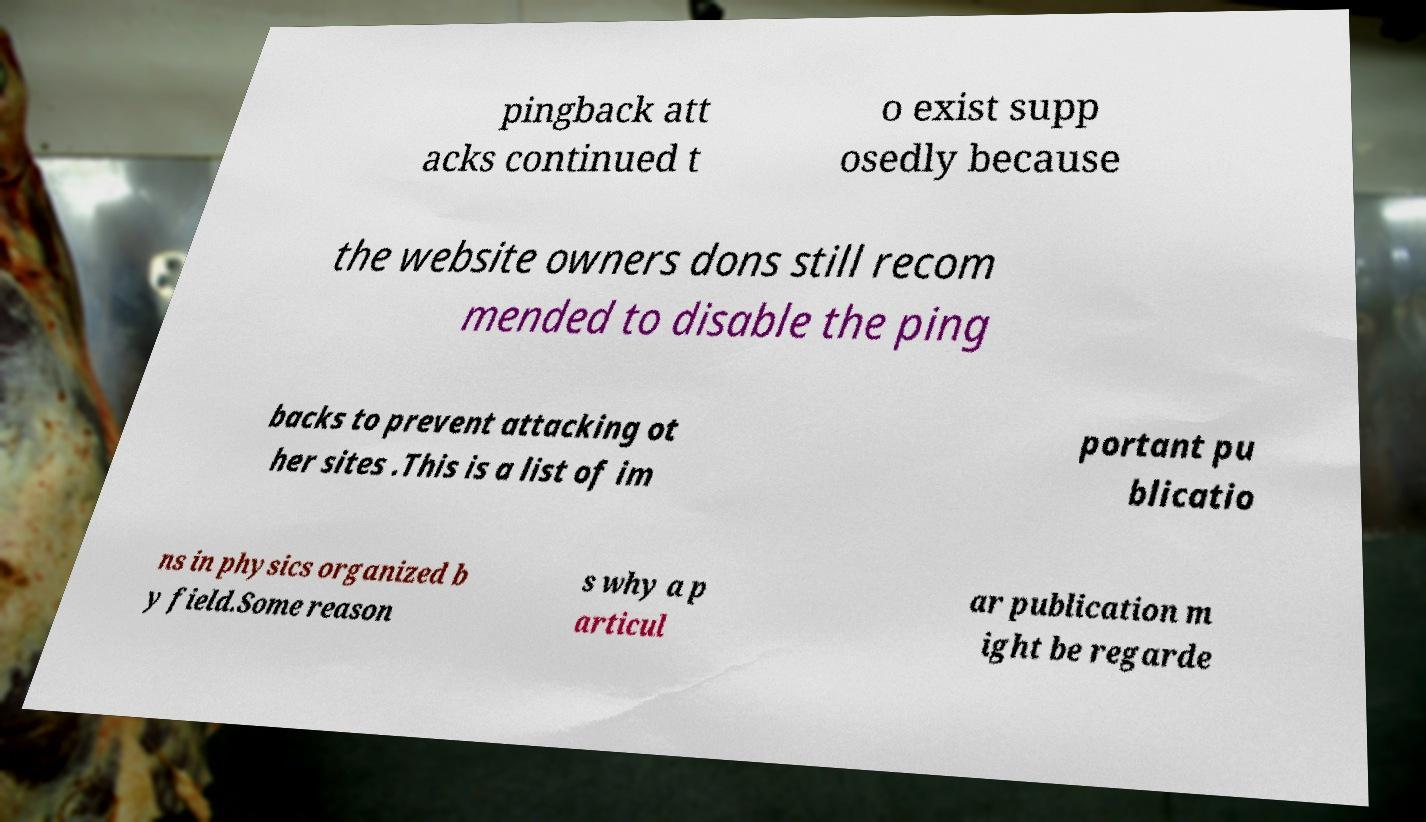Please identify and transcribe the text found in this image. pingback att acks continued t o exist supp osedly because the website owners dons still recom mended to disable the ping backs to prevent attacking ot her sites .This is a list of im portant pu blicatio ns in physics organized b y field.Some reason s why a p articul ar publication m ight be regarde 